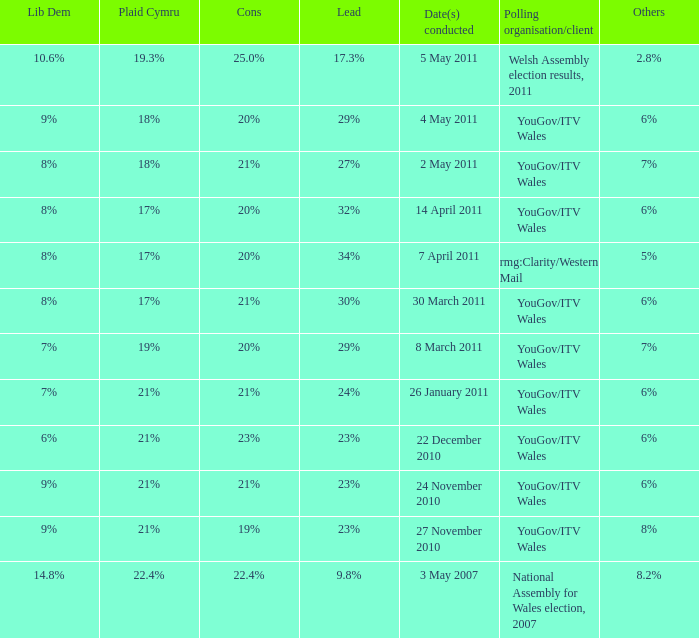What is the cons for lib dem of 8% and a lead of 27% 21%. 